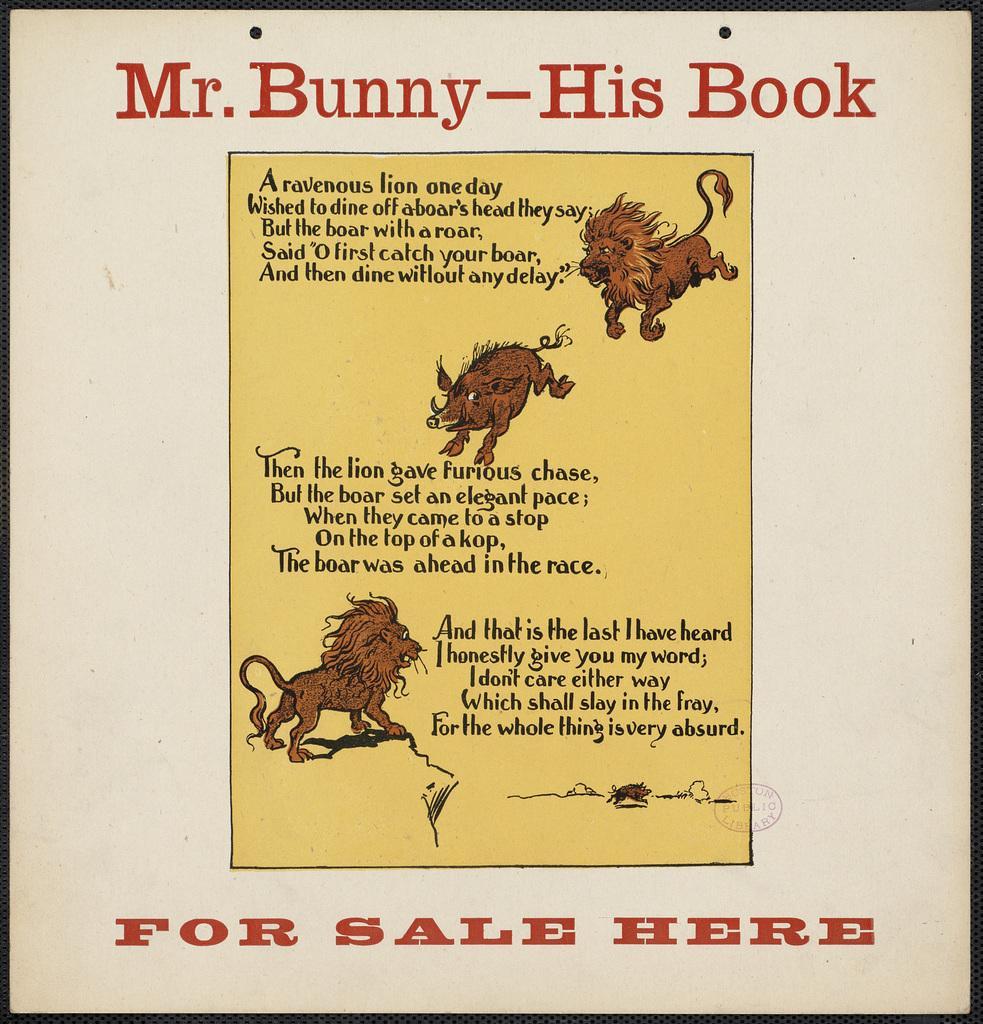Can you describe this image briefly? In this image there is a picture of a book cover with text and pictures on it. 